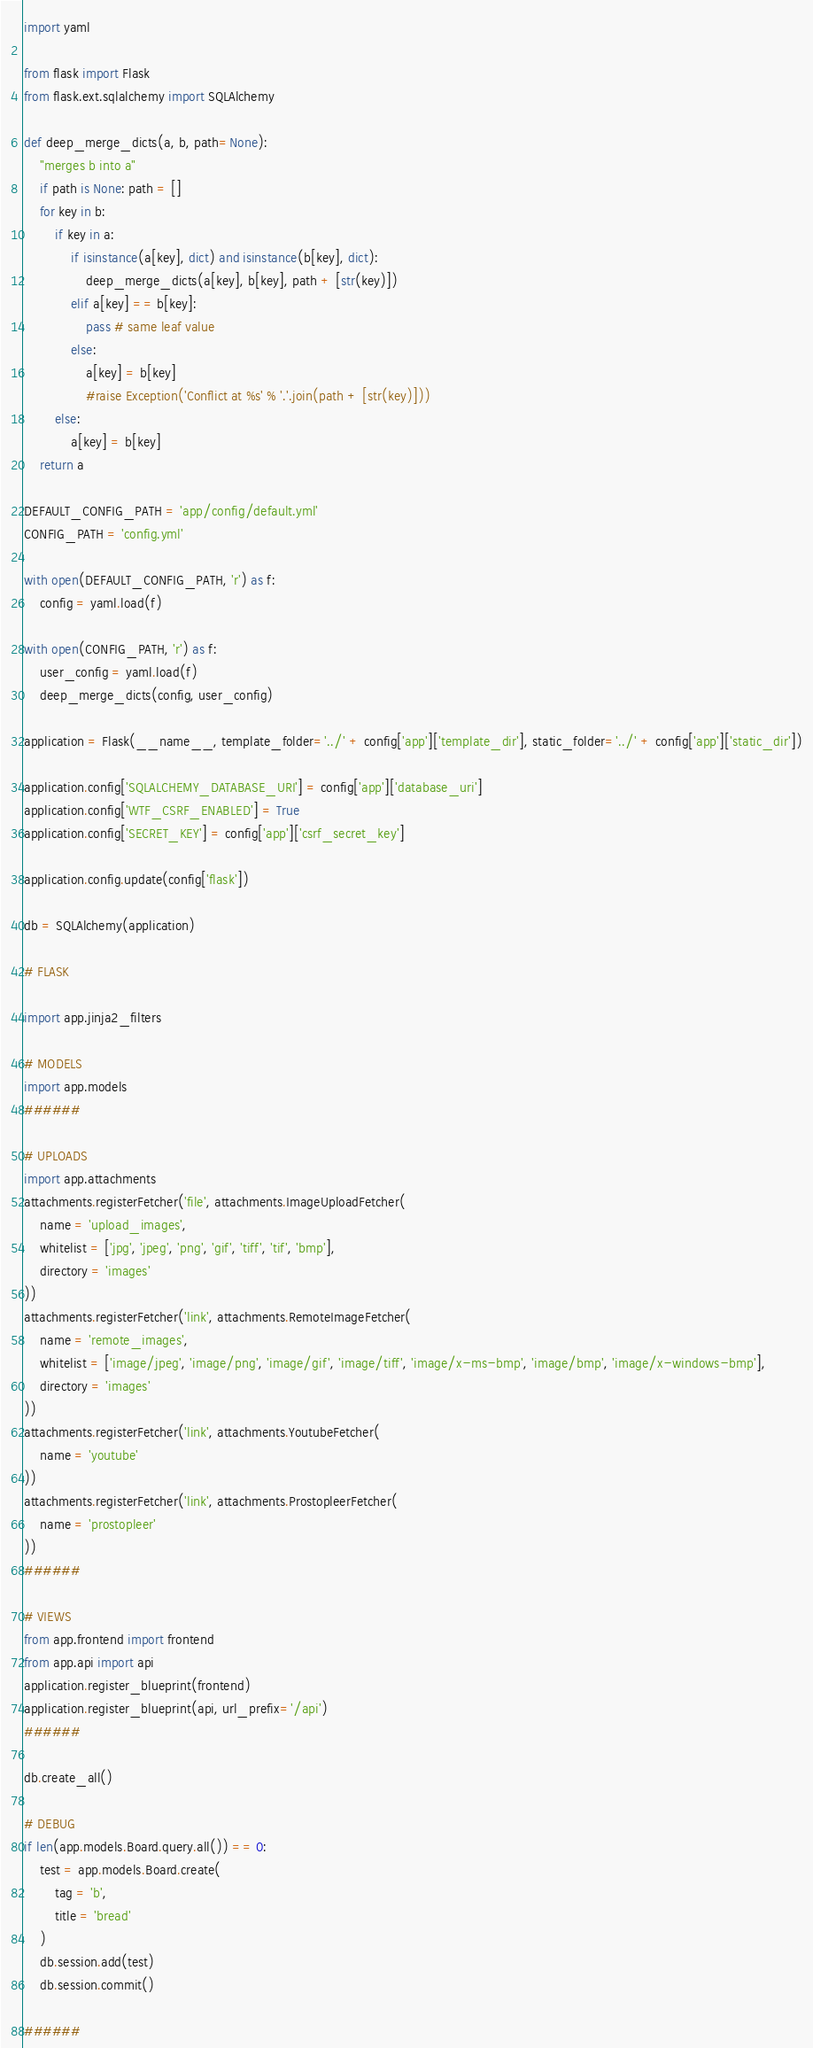<code> <loc_0><loc_0><loc_500><loc_500><_Python_>import yaml

from flask import Flask
from flask.ext.sqlalchemy import SQLAlchemy

def deep_merge_dicts(a, b, path=None):
    "merges b into a"
    if path is None: path = []
    for key in b:
        if key in a:
            if isinstance(a[key], dict) and isinstance(b[key], dict):
                deep_merge_dicts(a[key], b[key], path + [str(key)])
            elif a[key] == b[key]:
                pass # same leaf value
            else:
                a[key] = b[key]
                #raise Exception('Conflict at %s' % '.'.join(path + [str(key)]))
        else:
            a[key] = b[key]
    return a

DEFAULT_CONFIG_PATH = 'app/config/default.yml'
CONFIG_PATH = 'config.yml'

with open(DEFAULT_CONFIG_PATH, 'r') as f:
    config = yaml.load(f)

with open(CONFIG_PATH, 'r') as f:
    user_config = yaml.load(f)
    deep_merge_dicts(config, user_config)

application = Flask(__name__, template_folder='../' + config['app']['template_dir'], static_folder='../' + config['app']['static_dir'])

application.config['SQLALCHEMY_DATABASE_URI'] = config['app']['database_uri']
application.config['WTF_CSRF_ENABLED'] = True
application.config['SECRET_KEY'] = config['app']['csrf_secret_key']

application.config.update(config['flask'])

db = SQLAlchemy(application)

# FLASK

import app.jinja2_filters

# MODELS
import app.models
######

# UPLOADS
import app.attachments
attachments.registerFetcher('file', attachments.ImageUploadFetcher(
    name = 'upload_images',
    whitelist = ['jpg', 'jpeg', 'png', 'gif', 'tiff', 'tif', 'bmp'],
    directory = 'images'
))
attachments.registerFetcher('link', attachments.RemoteImageFetcher(
    name = 'remote_images',
    whitelist = ['image/jpeg', 'image/png', 'image/gif', 'image/tiff', 'image/x-ms-bmp', 'image/bmp', 'image/x-windows-bmp'],
    directory = 'images'
))
attachments.registerFetcher('link', attachments.YoutubeFetcher(
    name = 'youtube'
))
attachments.registerFetcher('link', attachments.ProstopleerFetcher(
    name = 'prostopleer'
))
######

# VIEWS
from app.frontend import frontend
from app.api import api
application.register_blueprint(frontend)
application.register_blueprint(api, url_prefix='/api')
######

db.create_all()

# DEBUG
if len(app.models.Board.query.all()) == 0:
    test = app.models.Board.create(
        tag = 'b',
        title = 'bread'    
    )
    db.session.add(test)
    db.session.commit()

######</code> 